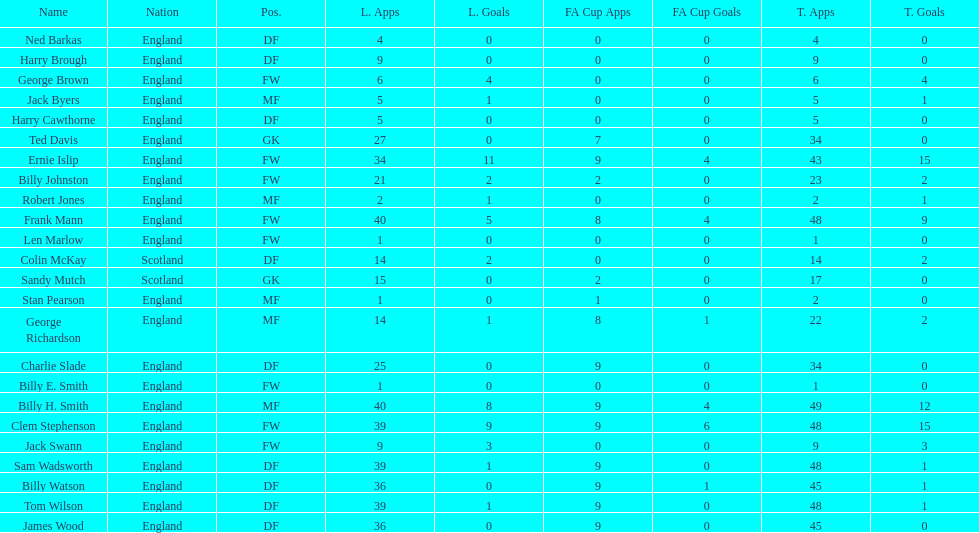Average number of goals scored by players from scotland 1. 